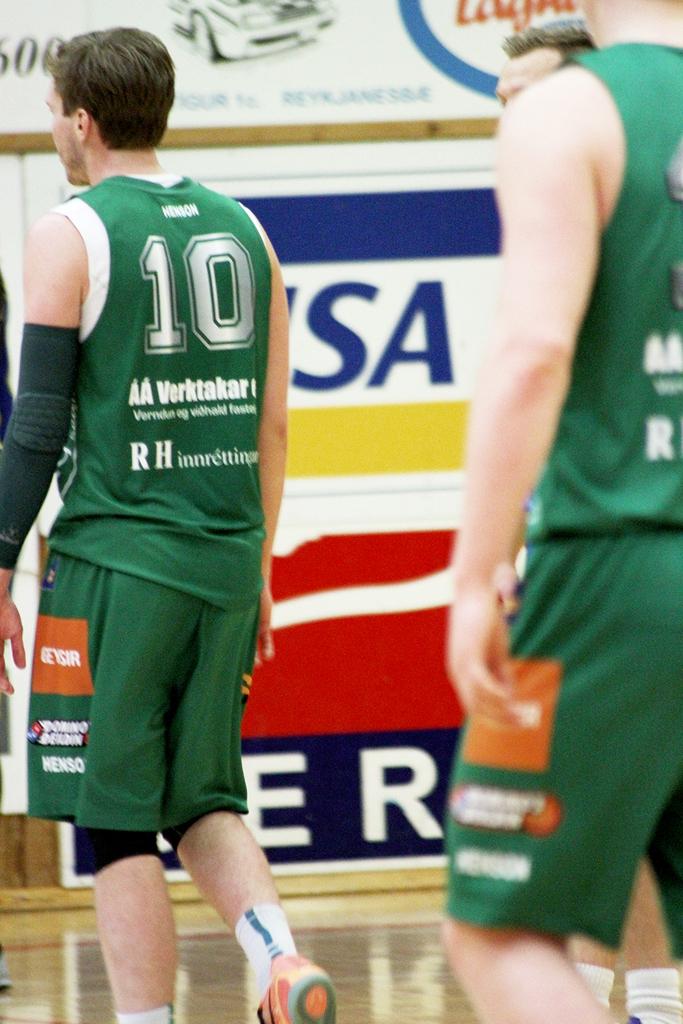What two letters are at the bottom of the mans shirt?
Keep it short and to the point. Rh. What is the players number?
Offer a very short reply. 10. 